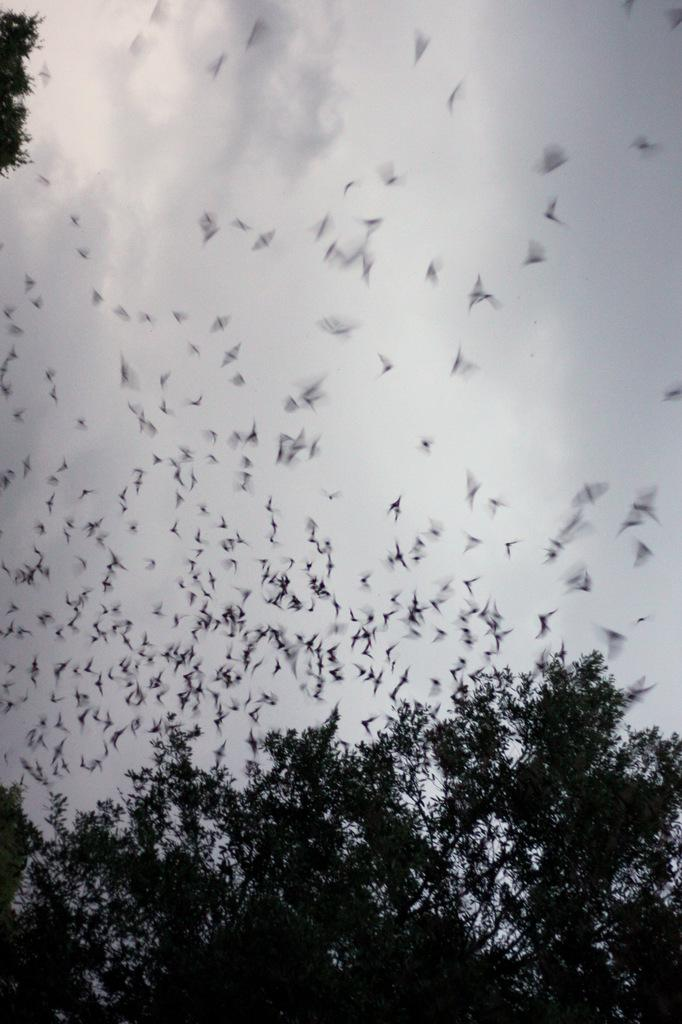What type of vegetation can be seen in the image? There are many trees in the image. What animals are visible in the image? Birds are flying in the image. What part of the natural environment is visible in the image? The sky is visible in the background of the image. What can be seen in the sky? Clouds are present in the sky. What type of bun is being used to hold the argument between the giants in the image? There are no giants or buns present in the image; it features birds flying among trees with a visible sky and clouds. 